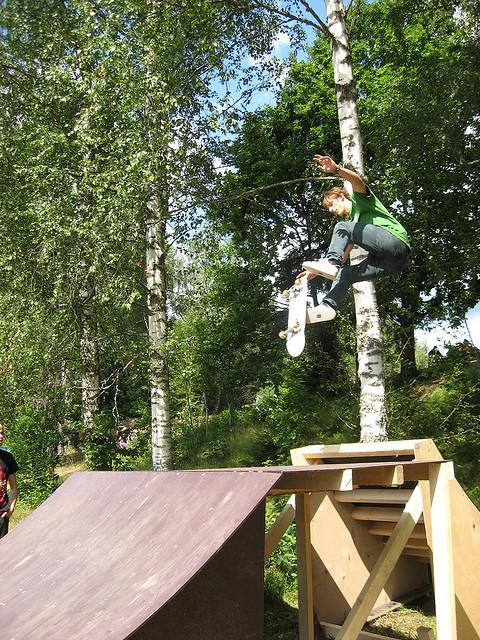What is this large contraption called? Please explain your reasoning. skateboarding ramp. The ramp can be used to ride skateboards up and down. 